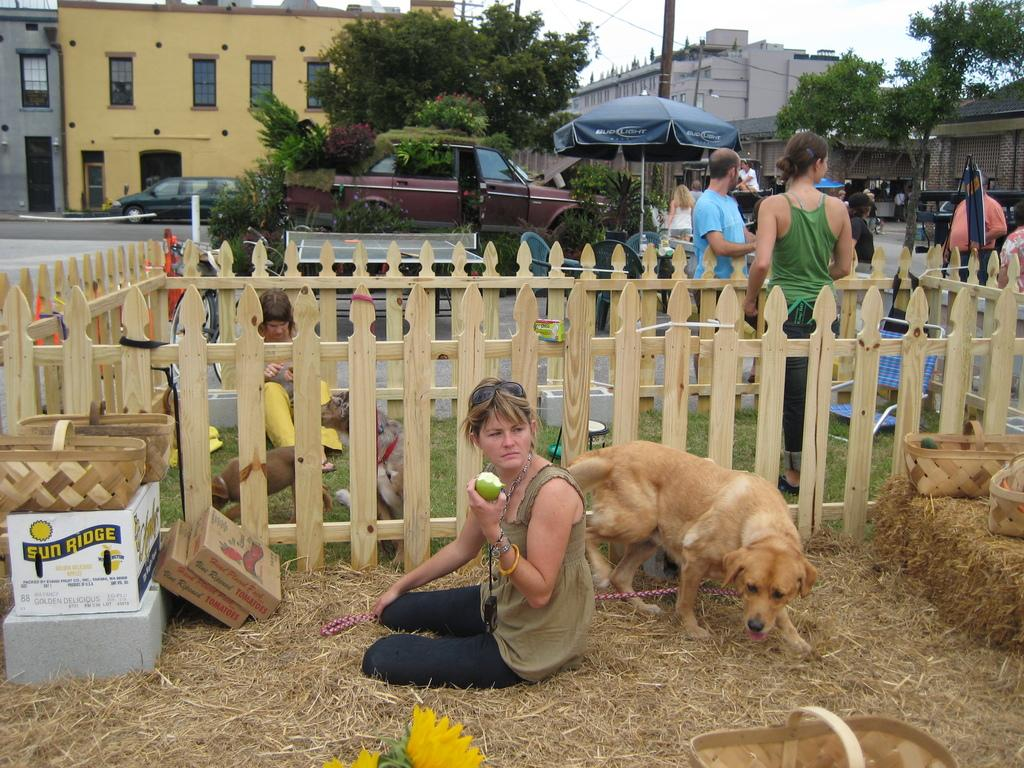What is the woman wearing in the image? The woman is wearing black pants in the image. What is the woman holding in the image? The woman is holding a fruit in the image. What can be seen behind the woman? There is a dog behind the woman in the image. What is visible in the background of the image? In the background, there are group of people, cars, trees, and buildings. What type of design can be seen on the farm in the image? There is no farm present in the image, and therefore no design can be observed. What kind of music is being played in the background of the image? There is no music present in the image, and therefore no specific genre can be identified. 